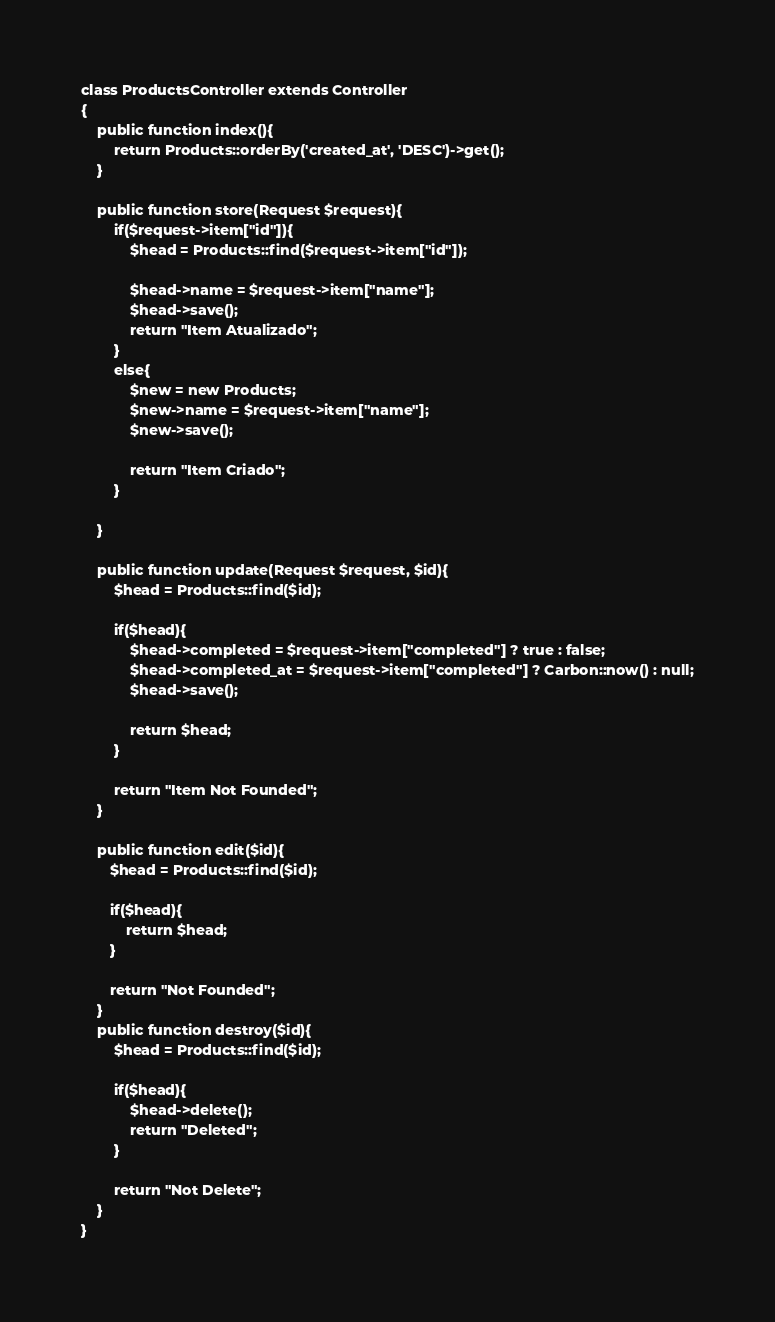<code> <loc_0><loc_0><loc_500><loc_500><_PHP_>class ProductsController extends Controller
{
    public function index(){
        return Products::orderBy('created_at', 'DESC')->get();
    }

    public function store(Request $request){
        if($request->item["id"]){
            $head = Products::find($request->item["id"]);

            $head->name = $request->item["name"];
            $head->save();
            return "Item Atualizado";
        }
        else{
            $new = new Products;
            $new->name = $request->item["name"];
            $new->save(); 
    
            return "Item Criado";
        }
        
    }

    public function update(Request $request, $id){
        $head = Products::find($id);

        if($head){
            $head->completed = $request->item["completed"] ? true : false;
            $head->completed_at = $request->item["completed"] ? Carbon::now() : null;
            $head->save();

            return $head;
        }

        return "Item Not Founded";
    }

    public function edit($id){
       $head = Products::find($id);

       if($head){
           return $head;
       }

       return "Not Founded";
    }
    public function destroy($id){
        $head = Products::find($id);

        if($head){
            $head->delete();
            return "Deleted";
        }

        return "Not Delete";
    }
}
</code> 